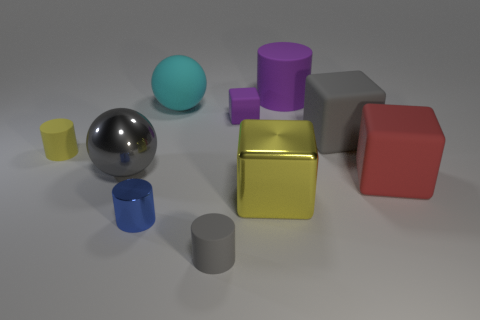Subtract 1 cubes. How many cubes are left? 3 Subtract all cylinders. How many objects are left? 6 Add 5 shiny things. How many shiny things exist? 8 Subtract 0 red balls. How many objects are left? 10 Subtract all large cyan matte things. Subtract all small purple objects. How many objects are left? 8 Add 6 small gray rubber cylinders. How many small gray rubber cylinders are left? 7 